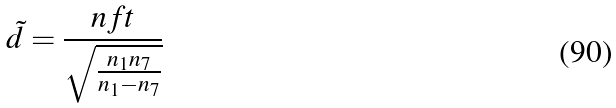<formula> <loc_0><loc_0><loc_500><loc_500>\tilde { d } = \frac { n f t } { \sqrt { \frac { n _ { 1 } n _ { 7 } } { n _ { 1 } - n _ { 7 } } } }</formula> 